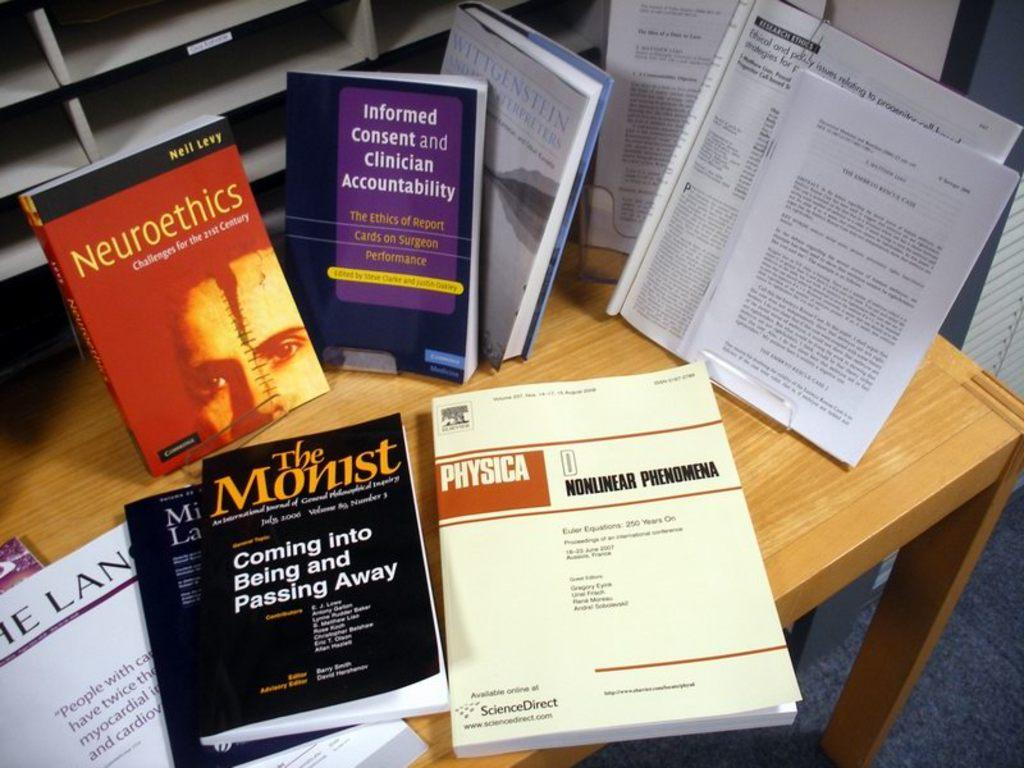<image>
Render a clear and concise summary of the photo. A book titled, "Nonlinear Phenomena" lays on a desk. 